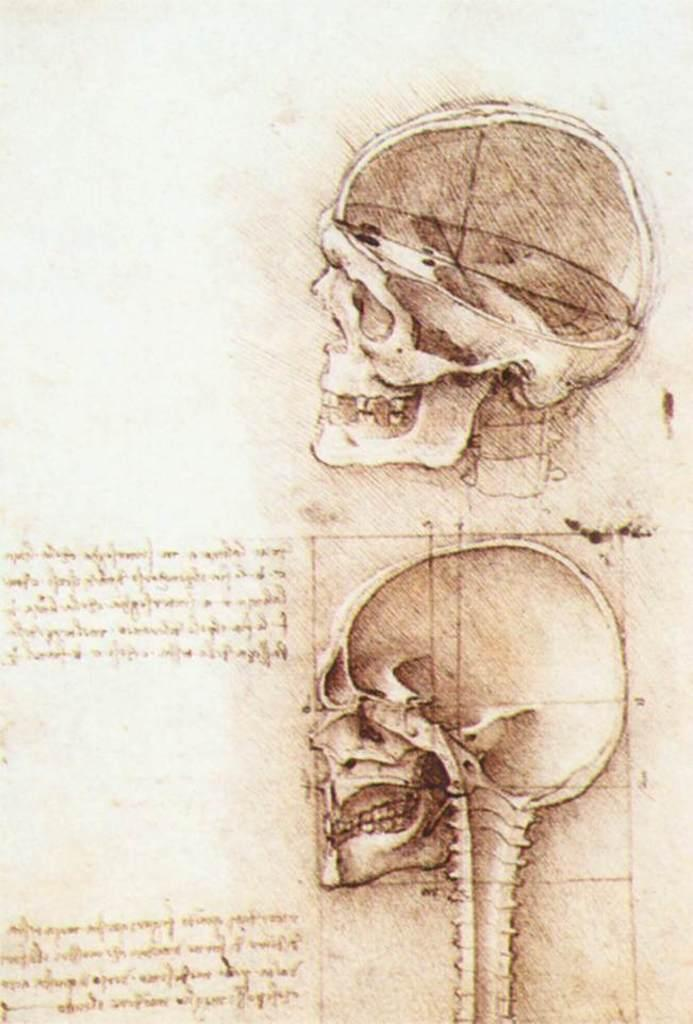What is depicted on the paper in the image? There is a picture of skulls on the paper. What else can be found on the paper besides the picture? There is text written on the paper. Can you see the crow smiling in the image? There is no crow present in the image, and therefore no such activity can be observed. 